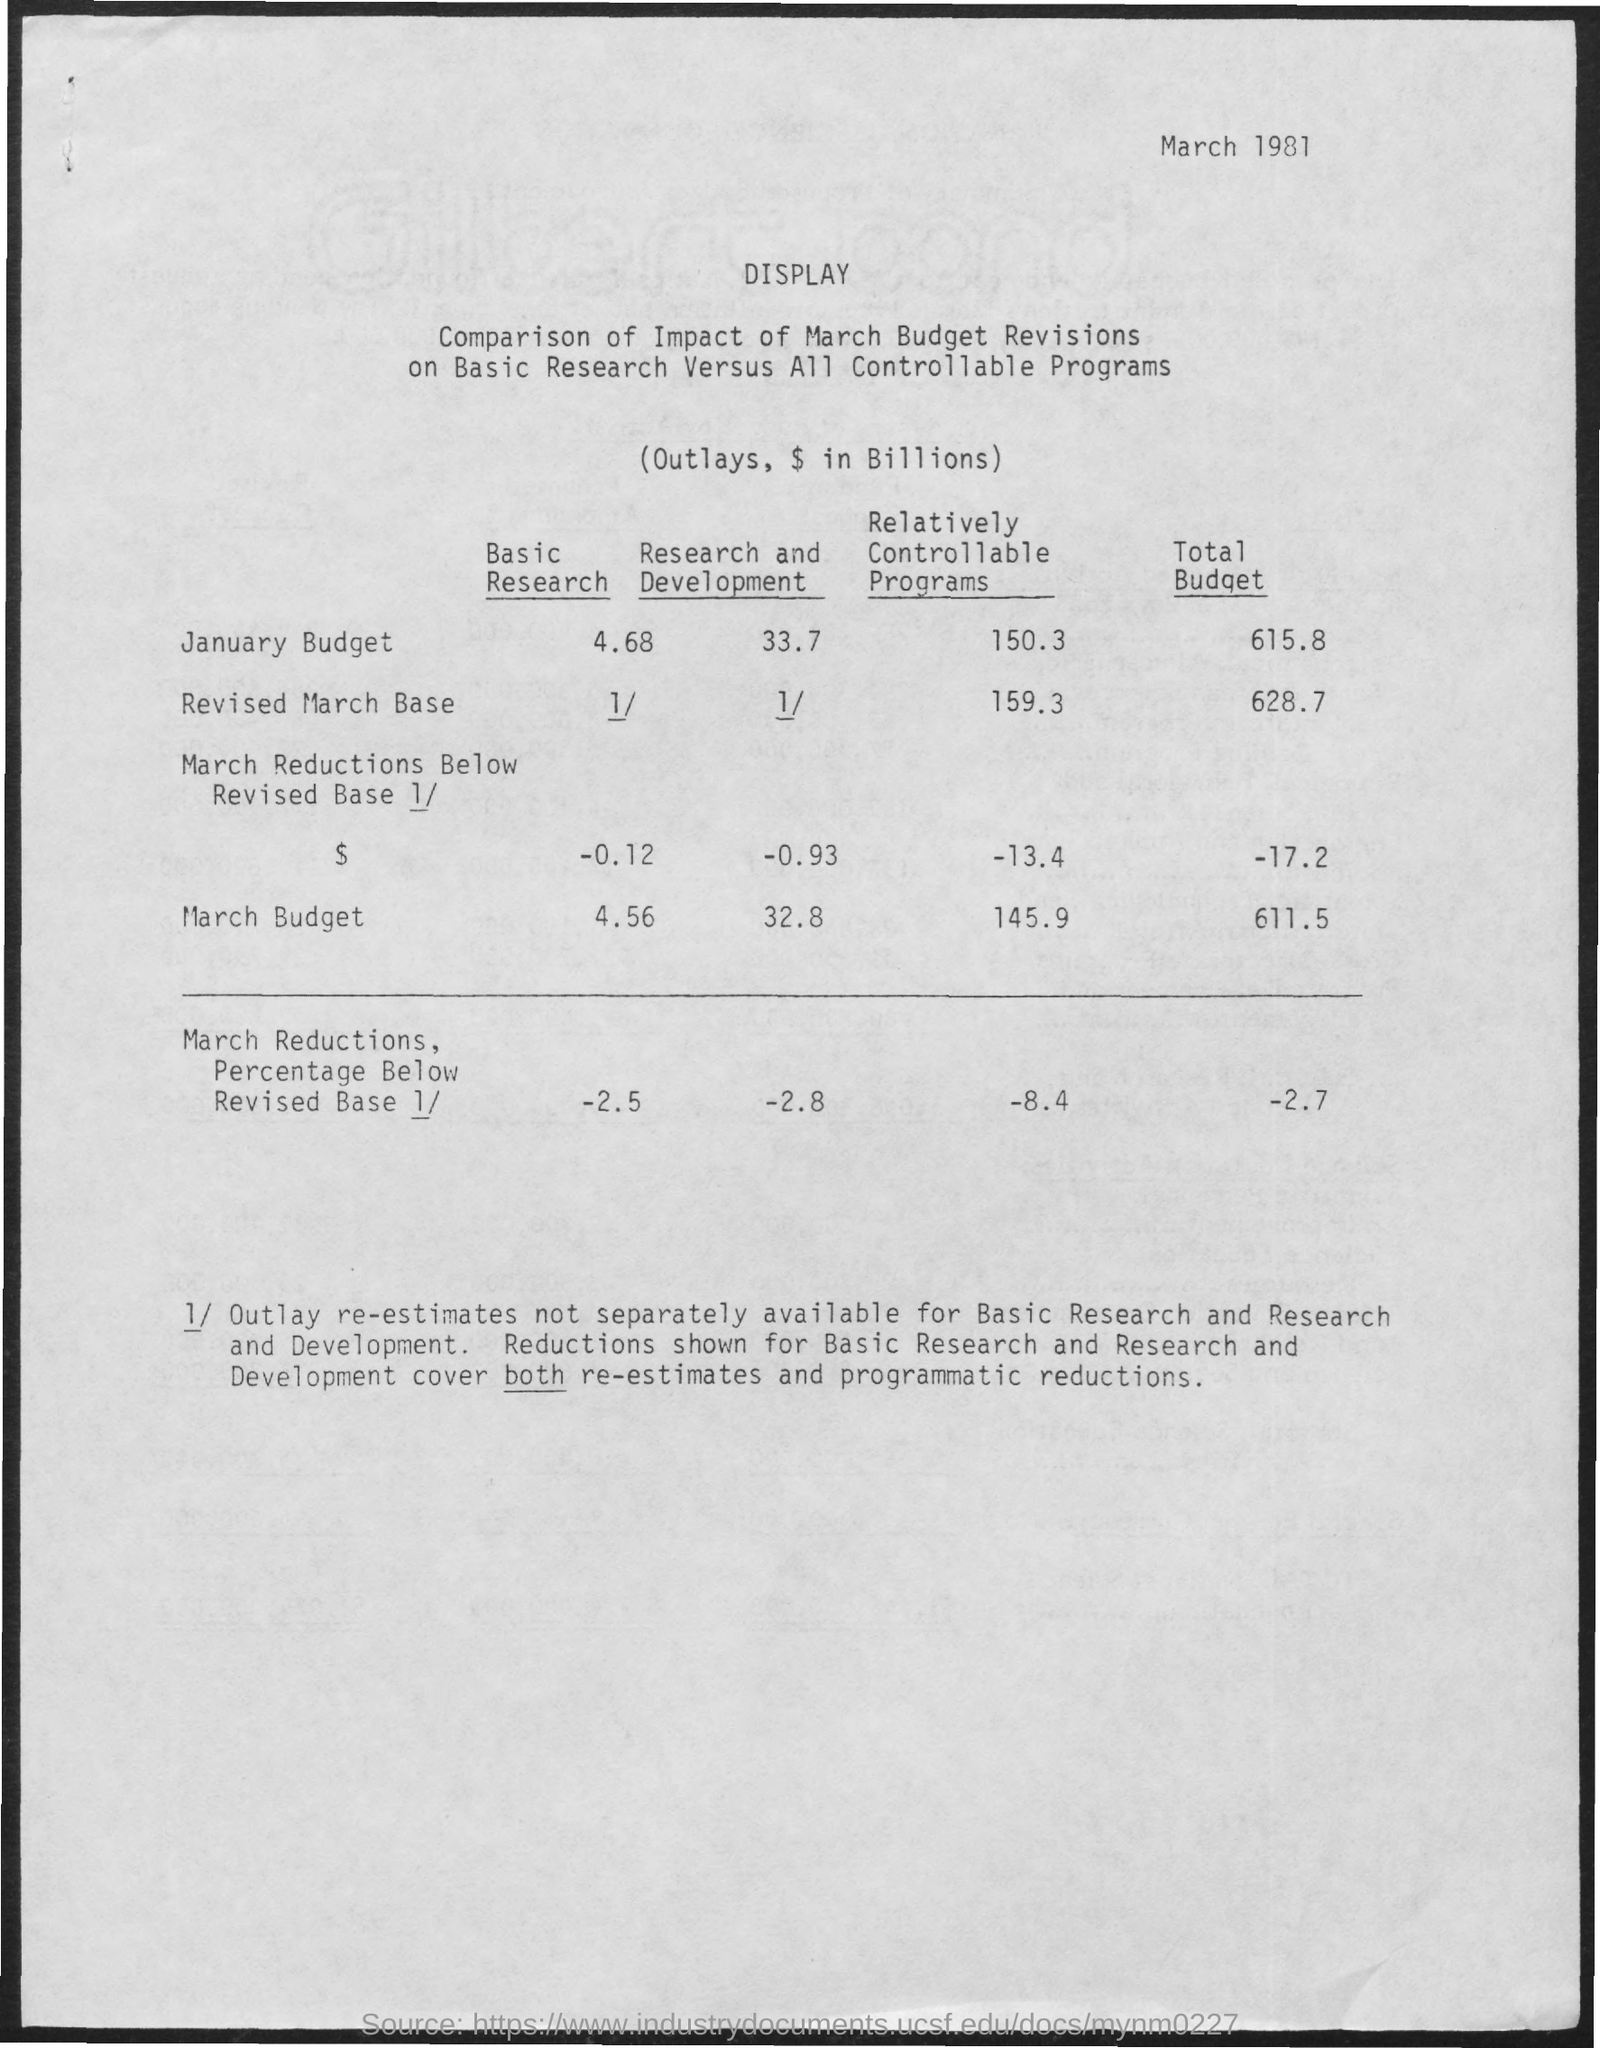What is the Relatively controllable programs for January Budget?
Your response must be concise. 150.3. What is the Relatively controllable programs for Revised March Base?
Make the answer very short. 159.3. What is the Relatively controllable programs for March Budget?
Provide a short and direct response. 145.9. What is the total Budget for January?
Give a very brief answer. 615.8. What is the total Budget for Revised March Base?
Offer a terse response. 628.7. What is the total Budget for March Budget?
Give a very brief answer. 611.5. What is the date on the document?
Keep it short and to the point. March 1981. 